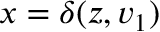Convert formula to latex. <formula><loc_0><loc_0><loc_500><loc_500>{ x = \delta ( z , v _ { 1 } ) }</formula> 